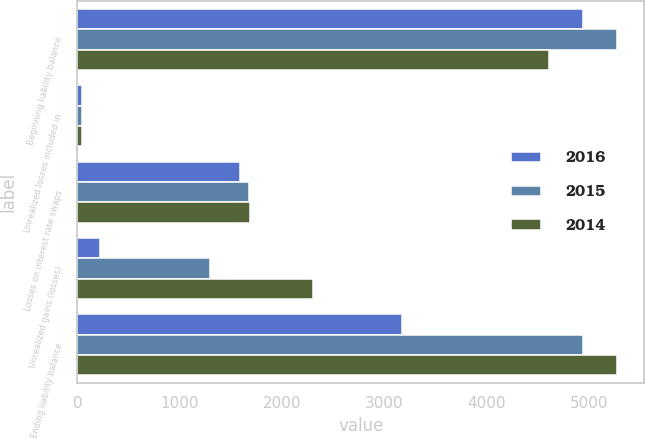<chart> <loc_0><loc_0><loc_500><loc_500><stacked_bar_chart><ecel><fcel>Beginning liability balance<fcel>Unrealized losses included in<fcel>Losses on interest rate swaps<fcel>Unrealized gains (losses)<fcel>Ending liability balance<nl><fcel>2016<fcel>4938<fcel>44<fcel>1586<fcel>221<fcel>3175<nl><fcel>2015<fcel>5273<fcel>44<fcel>1678<fcel>1299<fcel>4938<nl><fcel>2014<fcel>4604<fcel>48<fcel>1685<fcel>2306<fcel>5273<nl></chart> 